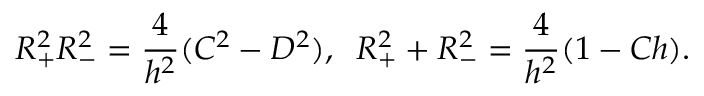Convert formula to latex. <formula><loc_0><loc_0><loc_500><loc_500>R _ { + } ^ { 2 } R _ { - } ^ { 2 } = \frac { 4 } { h ^ { 2 } } ( C ^ { 2 } - D ^ { 2 } ) , \, R _ { + } ^ { 2 } + R _ { - } ^ { 2 } = \frac { 4 } { h ^ { 2 } } ( 1 - C h ) .</formula> 